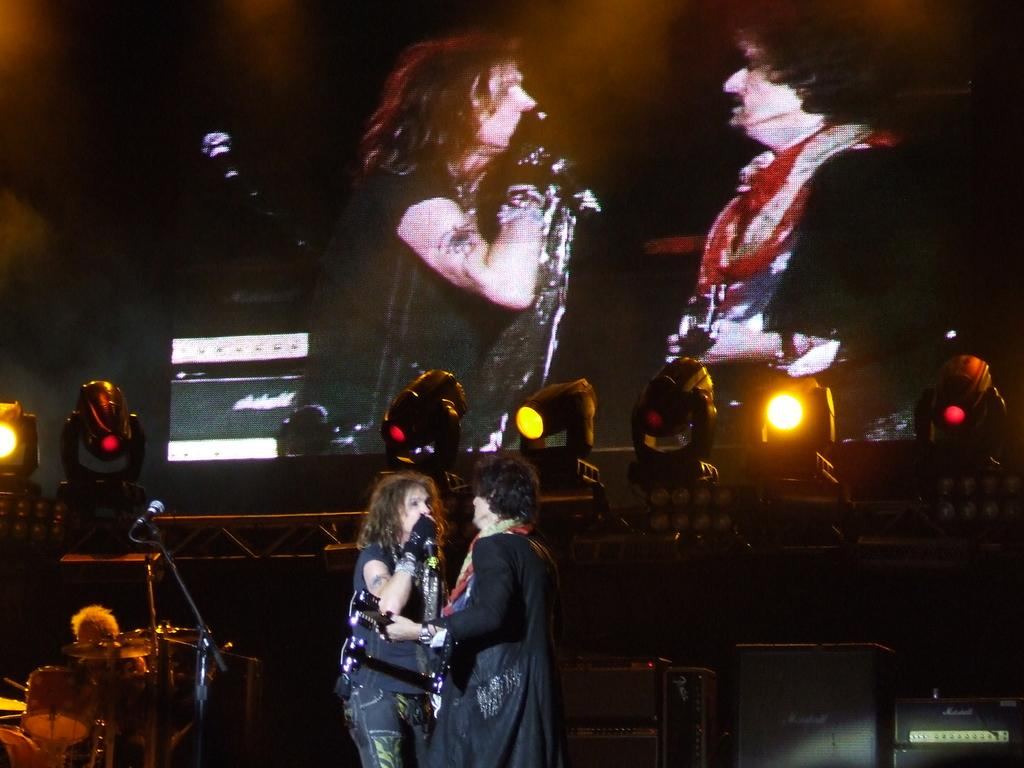What type of lights are present in the image? There are focusing lights in the image. What is located above the lights in the image? There is a screen on top in the image. How many women are in the image? Two women are standing in the image. What is one of the women doing in the image? One woman is singing into a microphone. What else can be seen in the image besides the lights and women? There are musical instruments in the image. Can you see a chessboard on the seashore in the image? There is no chessboard or seashore present in the image; it features focusing lights, a screen, two women, a microphone, and musical instruments. 